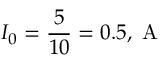Convert formula to latex. <formula><loc_0><loc_0><loc_500><loc_500>I _ { 0 } = \frac { 5 } { 1 0 } = 0 . 5 , A</formula> 